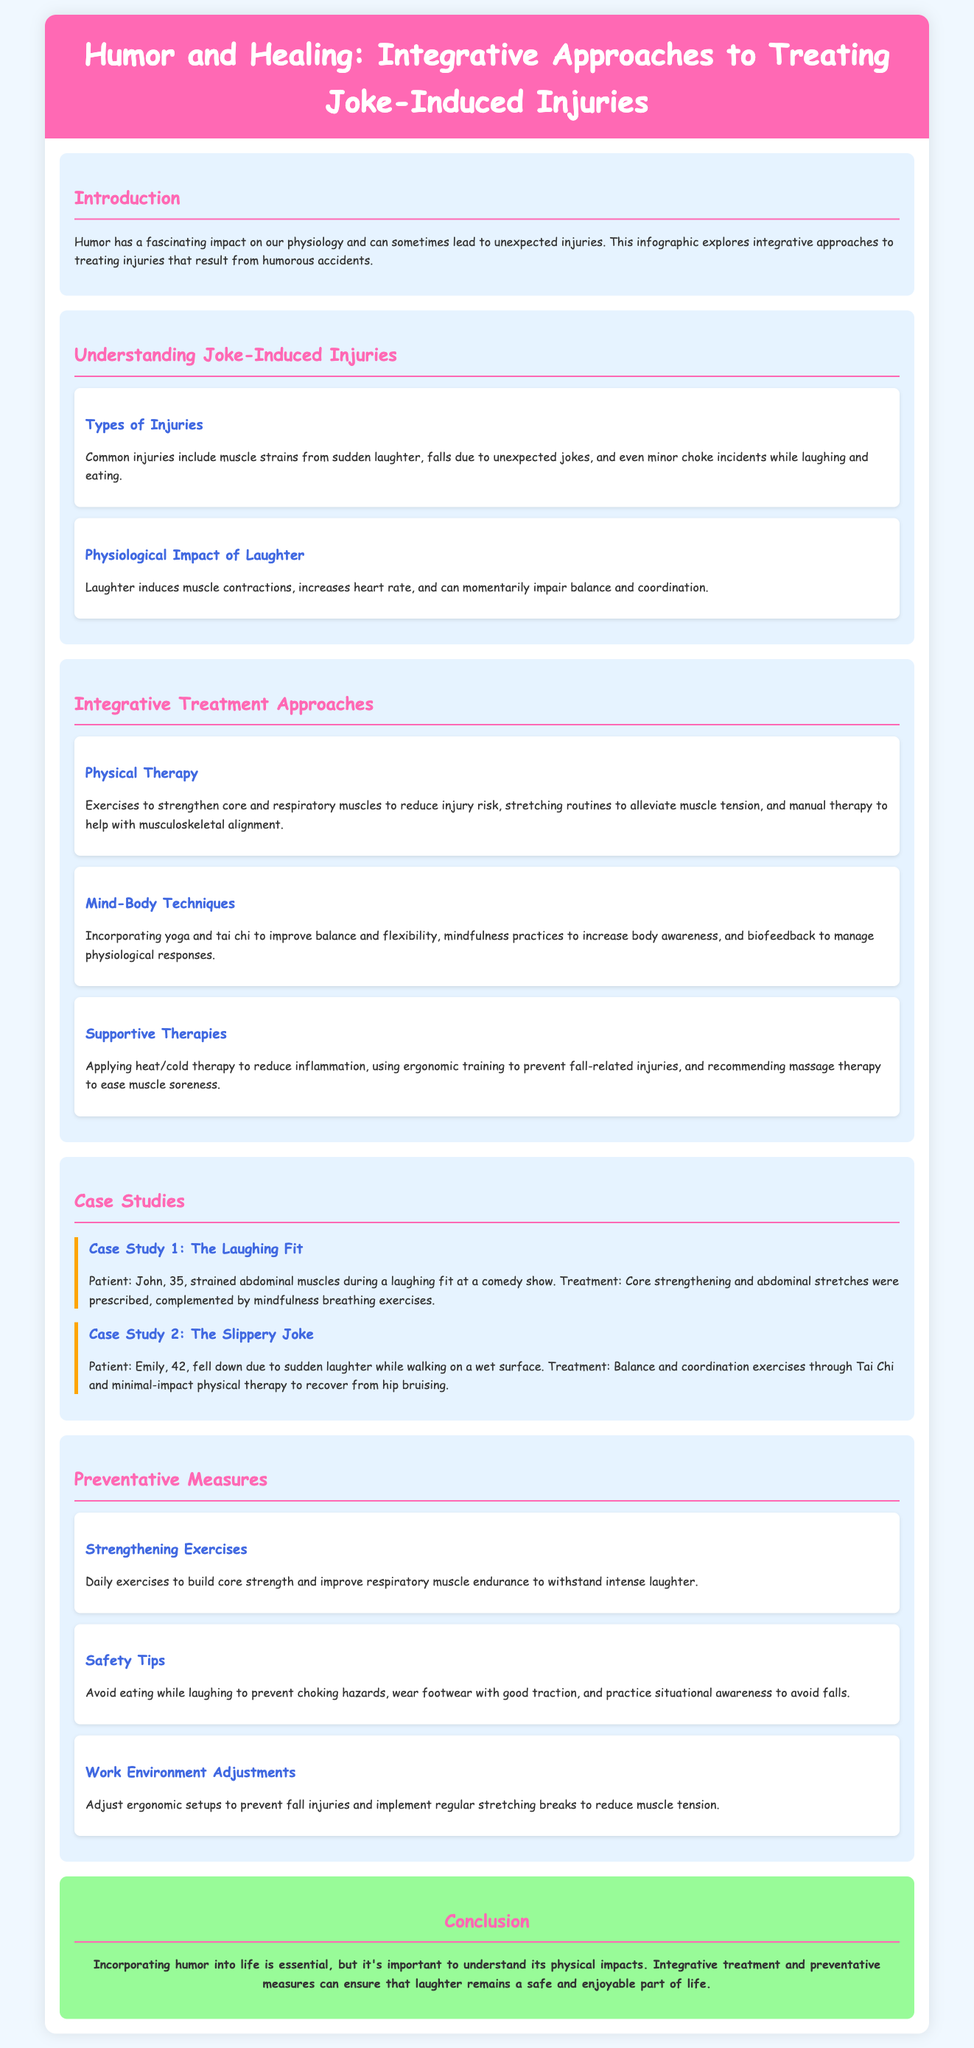what are common injuries mentioned? The document lists common injuries caused by humor, including muscle strains, falls, and choking incidents.
Answer: muscle strains, falls, choking incidents who is the patient in Case Study 1? The first case study mentions a patient named John.
Answer: John which physical therapy technique is recommended? The document suggests exercising to strengthen core and respiratory muscles as a physical therapy technique.
Answer: core strengthening what is one mind-body technique discussed? The document mentions yoga as a mind-body technique for improving balance and flexibility.
Answer: yoga what should be avoided to prevent choking hazards? The document advises against eating while laughing to prevent choking hazards.
Answer: eating while laughing what color is the conclusion section? The conclusion section is highlighted in a specific color distinct from others.
Answer: light green how many case studies are presented? The document details two case studies related to joke-induced injuries.
Answer: two what type of therapy applies heat/cold to reduce inflammation? The document categorizes the application of heat/cold therapy as a supportive therapy.
Answer: supportive therapy what is one example of a safety tip given? The document includes wearing footwear with good traction as a safety tip.
Answer: good traction footwear 